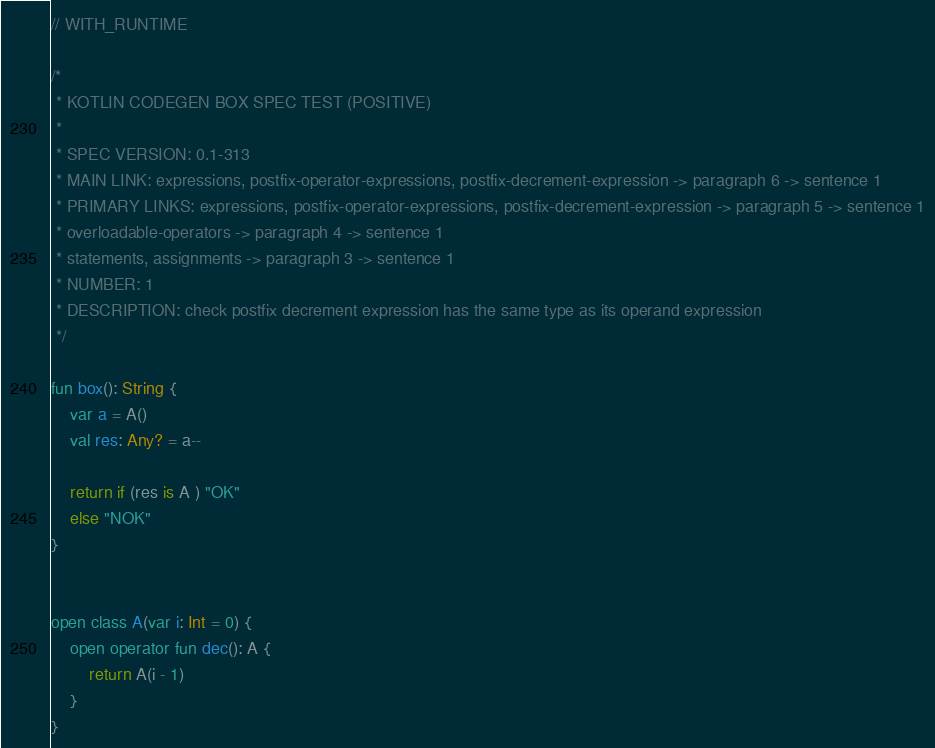Convert code to text. <code><loc_0><loc_0><loc_500><loc_500><_Kotlin_>// WITH_RUNTIME

/*
 * KOTLIN CODEGEN BOX SPEC TEST (POSITIVE)
 *
 * SPEC VERSION: 0.1-313
 * MAIN LINK: expressions, postfix-operator-expressions, postfix-decrement-expression -> paragraph 6 -> sentence 1
 * PRIMARY LINKS: expressions, postfix-operator-expressions, postfix-decrement-expression -> paragraph 5 -> sentence 1
 * overloadable-operators -> paragraph 4 -> sentence 1
 * statements, assignments -> paragraph 3 -> sentence 1
 * NUMBER: 1
 * DESCRIPTION: check postfix decrement expression has the same type as its operand expression
 */

fun box(): String {
    var a = A()
    val res: Any? = a--

    return if (res is A ) "OK"
    else "NOK"
}


open class A(var i: Int = 0) {
    open operator fun dec(): A {
        return A(i - 1)
    }
}</code> 